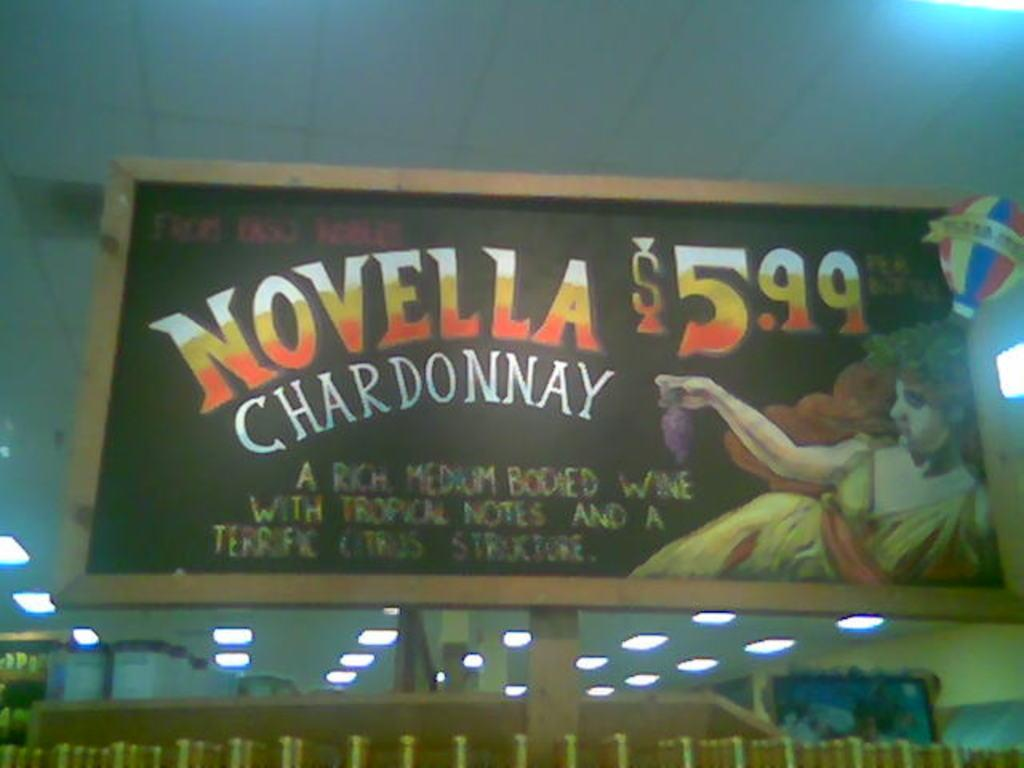<image>
Provide a brief description of the given image. a sign for Novella Chardonnay for $5.99 on display 